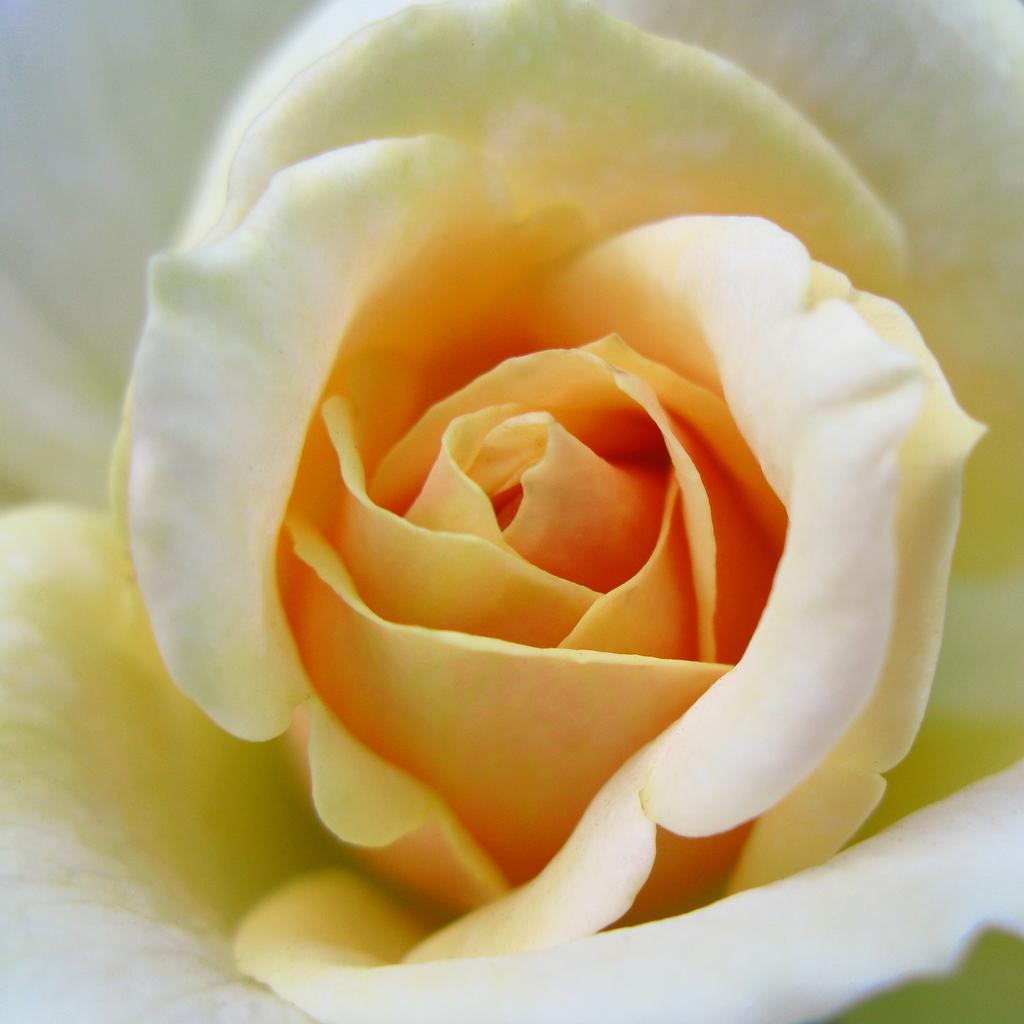Could you give a brief overview of what you see in this image? In this image there is a beautiful white rose. 